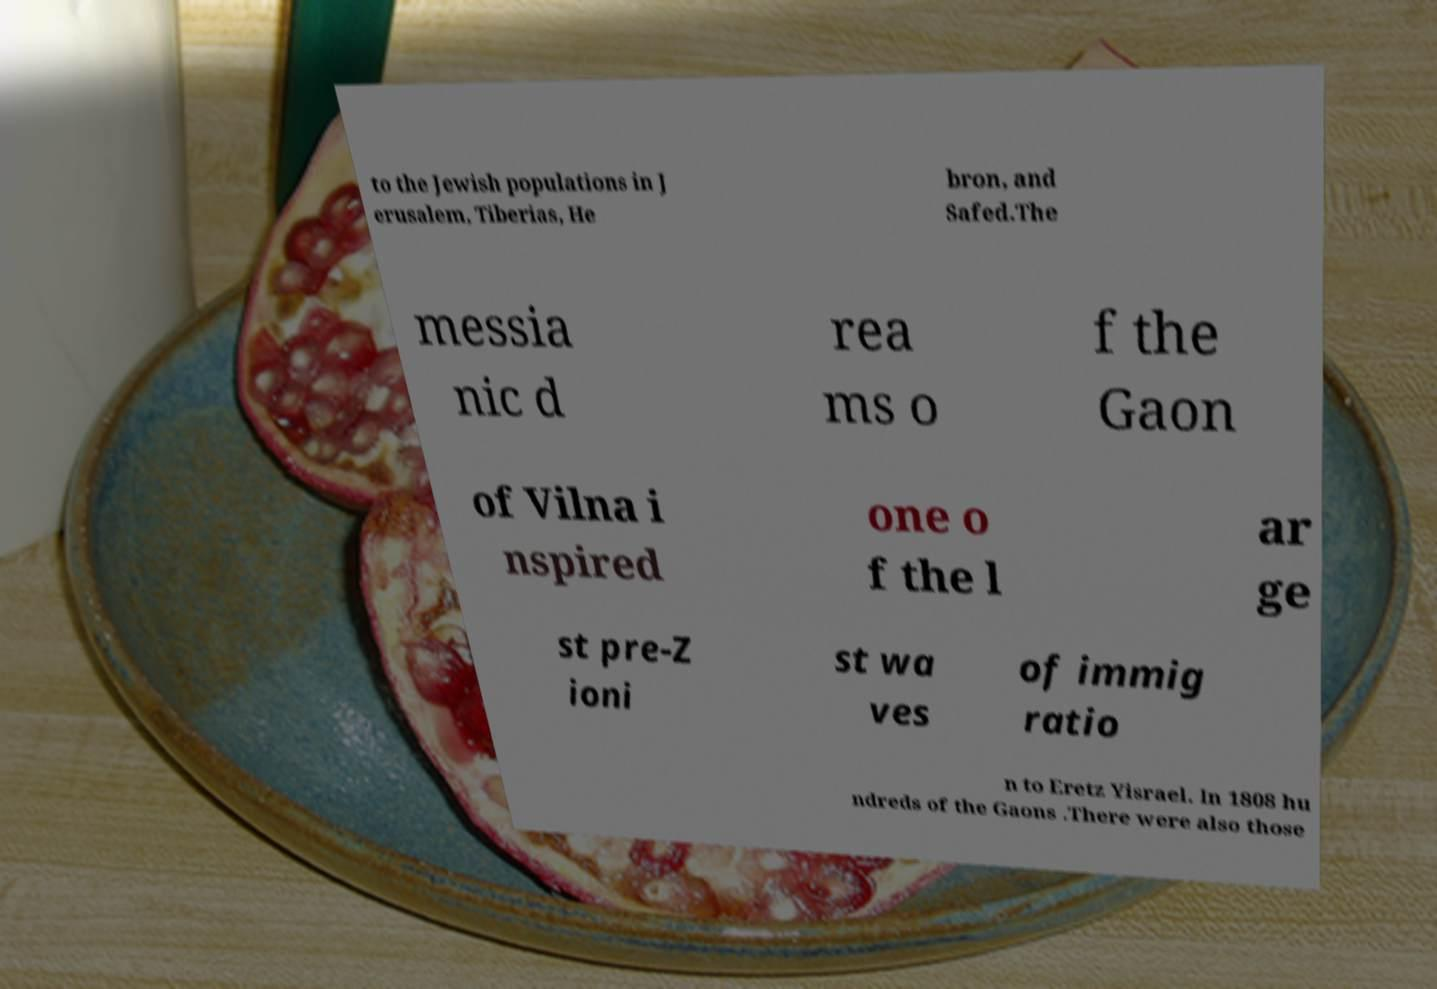Can you accurately transcribe the text from the provided image for me? to the Jewish populations in J erusalem, Tiberias, He bron, and Safed.The messia nic d rea ms o f the Gaon of Vilna i nspired one o f the l ar ge st pre-Z ioni st wa ves of immig ratio n to Eretz Yisrael. In 1808 hu ndreds of the Gaons .There were also those 